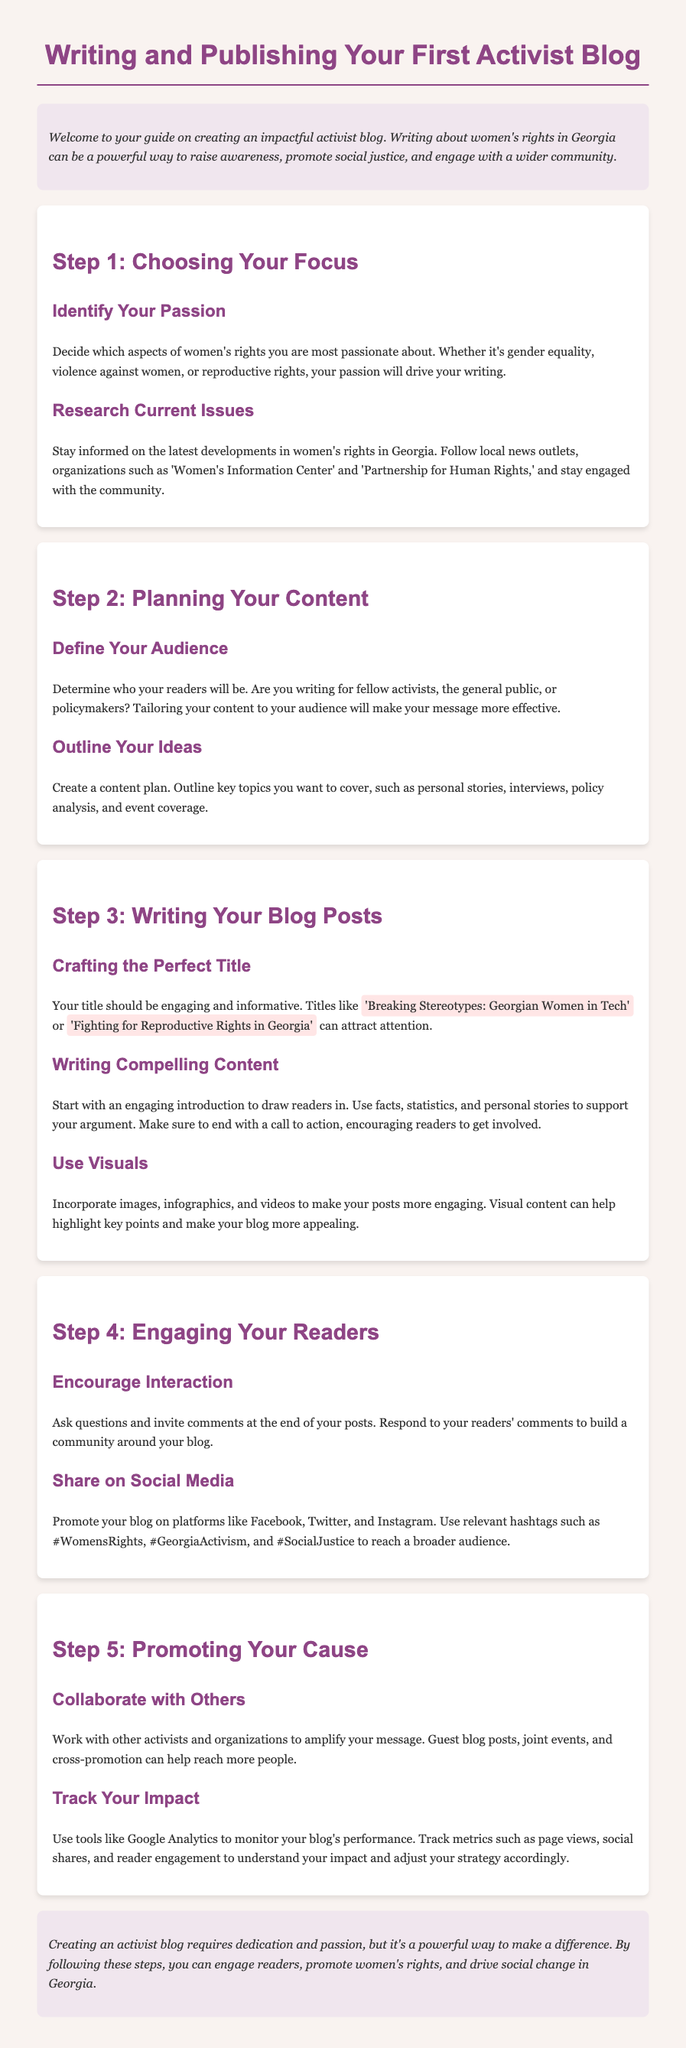What is the main focus of the guide? The guide focuses on creating an impactful activist blog on women's rights.
Answer: women's rights Which organizations are mentioned for staying informed? The guide includes specific organizations to follow for updates on women's rights issues.
Answer: Women's Information Center and Partnership for Human Rights What should the title of a blog post do? The guide explains the purpose of a blog post title in attracting readers.
Answer: be engaging and informative Name one method to promote your blog. The document suggests strategies for promoting blog posts effectively.
Answer: Share on social media What is a recommended way to engage readers? The guide advises on reader interaction methods.
Answer: Encourage interaction How can you track your blog's performance? The guide lists tools for monitoring the impact of your blog.
Answer: Google Analytics What is one type of content you should visualize? The guide mentions specific content types to enhance engagement using visuals.
Answer: images What is the purpose of a call to action? The guide highlights the importance of ending blog posts with a specific encouragement.
Answer: Encouraging readers to get involved How many steps are included in the guide? The guide is structured into multiple steps aimed at helping new bloggers.
Answer: five steps 